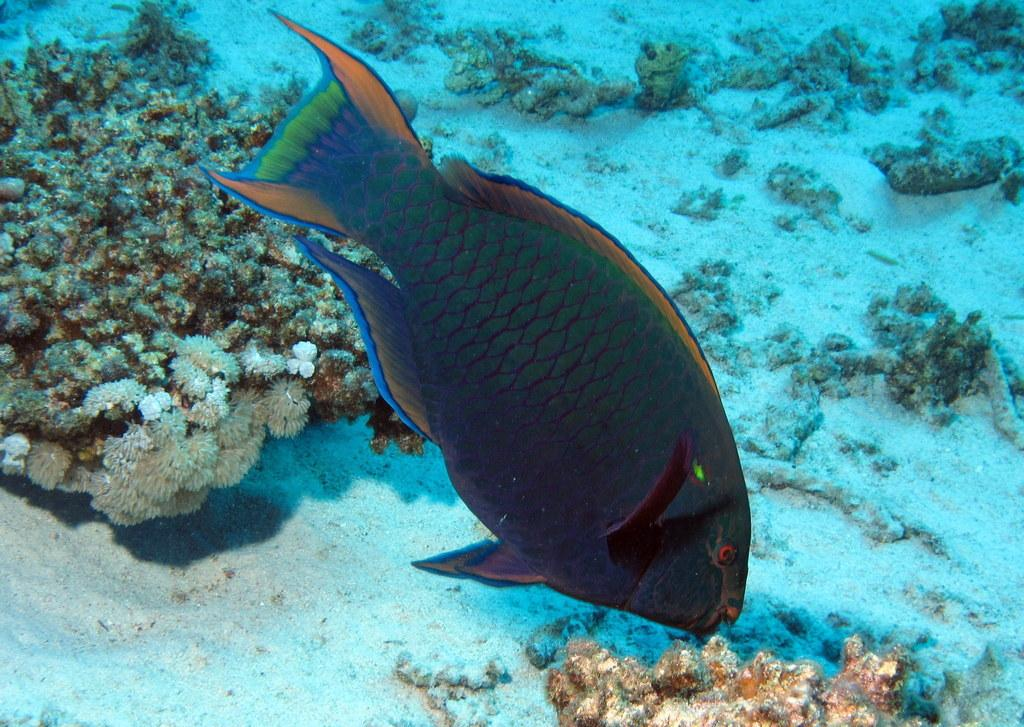What type of environment is shown in the image? The image depicts an underwater environment. What can be seen swimming in the water? There is a fish in the water. What is located on the left side of the image? There is a plant on the left side of the image. Can you see your mom holding a bone in the image? There is no person, including your mom, present in the image, and therefore no one is holding a bone. 